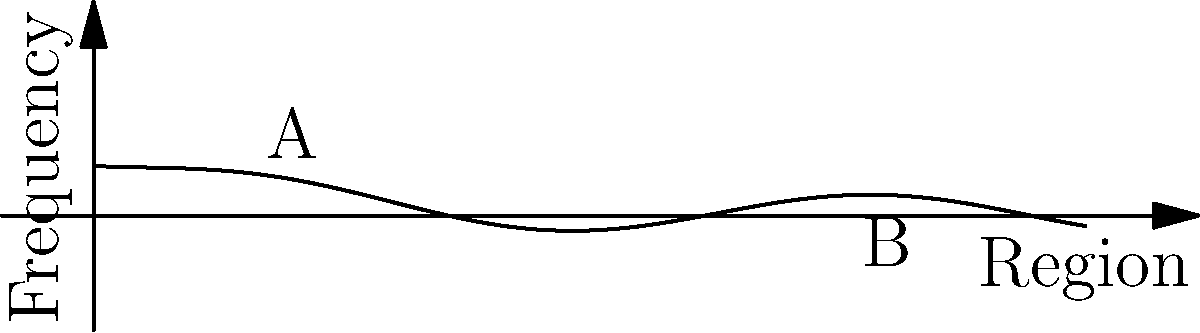The curve above represents the frequency of the surname "Smith" across different regions. If the x-axis represents the region number and the y-axis represents the frequency, calculate the total area under the curve between regions 2 and 8. Use the trapezoidal rule with 6 subintervals to approximate the result. To solve this problem using the trapezoidal rule with 6 subintervals, we'll follow these steps:

1) The trapezoidal rule formula is:

   $$\int_{a}^{b} f(x)dx \approx \frac{h}{2}[f(a) + 2f(x_1) + 2f(x_2) + ... + 2f(x_{n-1}) + f(b)]$$

   where $h = \frac{b-a}{n}$, and $n$ is the number of subintervals.

2) In our case, $a=2$, $b=8$, and $n=6$.

3) Calculate $h$:
   $$h = \frac{8-2}{6} = 1$$

4) Calculate the x-values for each point:
   $x_0 = 2$, $x_1 = 3$, $x_2 = 4$, $x_3 = 5$, $x_4 = 6$, $x_5 = 7$, $x_6 = 8$

5) Calculate $f(x)$ for each point using the given function:
   $$f(x) = 0.5e^{-0.5x} + 0.2\sin(x)$$

   $f(2) \approx 0.4323$
   $f(3) \approx 0.3679$
   $f(4) \approx 0.3085$
   $f(5) \approx 0.2528$
   $f(6) \approx 0.2020$
   $f(7) \approx 0.1569$
   $f(8) \approx 0.1179$

6) Apply the trapezoidal rule:

   $$\text{Area} \approx \frac{1}{2}[0.4323 + 2(0.3679 + 0.3085 + 0.2528 + 0.2020 + 0.1569) + 0.1179]$$

7) Simplify:
   $$\text{Area} \approx \frac{1}{2}[0.4323 + 2(1.2881) + 0.1179]$$
   $$\text{Area} \approx \frac{1}{2}[0.4323 + 2.5762 + 0.1179]$$
   $$\text{Area} \approx \frac{3.1264}{2}$$
   $$\text{Area} \approx 1.5632$$

Therefore, the approximate area under the curve between regions 2 and 8 is 1.5632.
Answer: 1.5632 